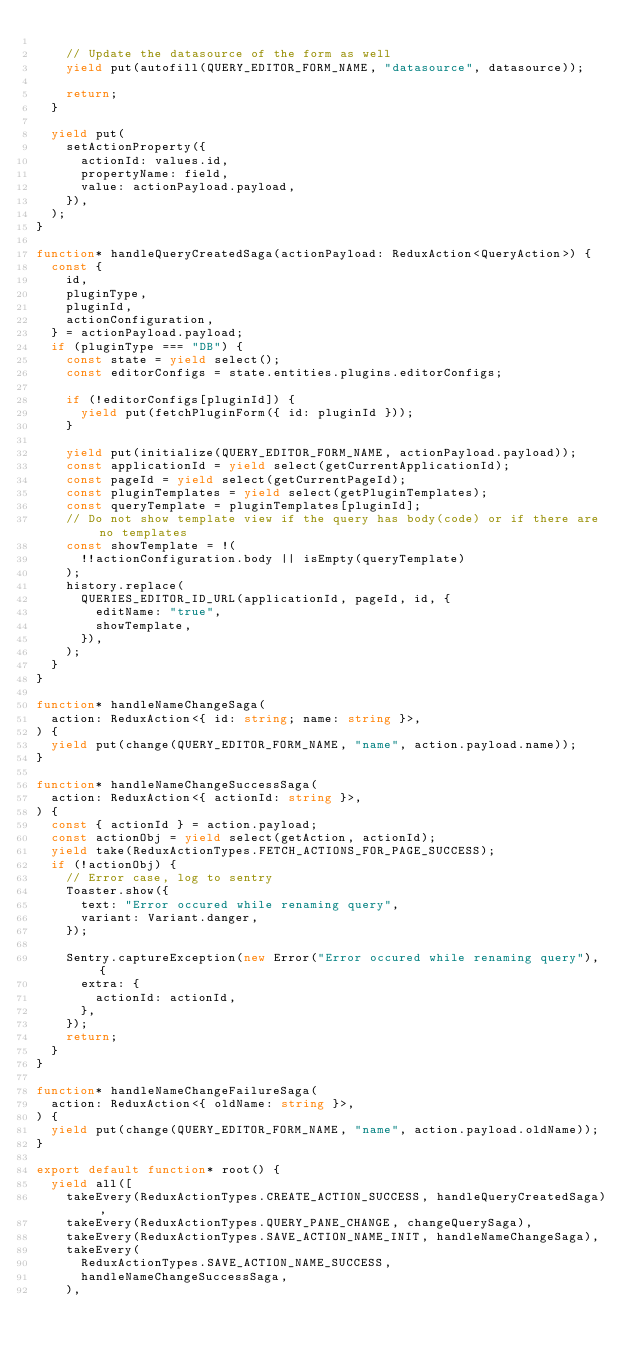<code> <loc_0><loc_0><loc_500><loc_500><_TypeScript_>
    // Update the datasource of the form as well
    yield put(autofill(QUERY_EDITOR_FORM_NAME, "datasource", datasource));

    return;
  }

  yield put(
    setActionProperty({
      actionId: values.id,
      propertyName: field,
      value: actionPayload.payload,
    }),
  );
}

function* handleQueryCreatedSaga(actionPayload: ReduxAction<QueryAction>) {
  const {
    id,
    pluginType,
    pluginId,
    actionConfiguration,
  } = actionPayload.payload;
  if (pluginType === "DB") {
    const state = yield select();
    const editorConfigs = state.entities.plugins.editorConfigs;

    if (!editorConfigs[pluginId]) {
      yield put(fetchPluginForm({ id: pluginId }));
    }

    yield put(initialize(QUERY_EDITOR_FORM_NAME, actionPayload.payload));
    const applicationId = yield select(getCurrentApplicationId);
    const pageId = yield select(getCurrentPageId);
    const pluginTemplates = yield select(getPluginTemplates);
    const queryTemplate = pluginTemplates[pluginId];
    // Do not show template view if the query has body(code) or if there are no templates
    const showTemplate = !(
      !!actionConfiguration.body || isEmpty(queryTemplate)
    );
    history.replace(
      QUERIES_EDITOR_ID_URL(applicationId, pageId, id, {
        editName: "true",
        showTemplate,
      }),
    );
  }
}

function* handleNameChangeSaga(
  action: ReduxAction<{ id: string; name: string }>,
) {
  yield put(change(QUERY_EDITOR_FORM_NAME, "name", action.payload.name));
}

function* handleNameChangeSuccessSaga(
  action: ReduxAction<{ actionId: string }>,
) {
  const { actionId } = action.payload;
  const actionObj = yield select(getAction, actionId);
  yield take(ReduxActionTypes.FETCH_ACTIONS_FOR_PAGE_SUCCESS);
  if (!actionObj) {
    // Error case, log to sentry
    Toaster.show({
      text: "Error occured while renaming query",
      variant: Variant.danger,
    });

    Sentry.captureException(new Error("Error occured while renaming query"), {
      extra: {
        actionId: actionId,
      },
    });
    return;
  }
}

function* handleNameChangeFailureSaga(
  action: ReduxAction<{ oldName: string }>,
) {
  yield put(change(QUERY_EDITOR_FORM_NAME, "name", action.payload.oldName));
}

export default function* root() {
  yield all([
    takeEvery(ReduxActionTypes.CREATE_ACTION_SUCCESS, handleQueryCreatedSaga),
    takeEvery(ReduxActionTypes.QUERY_PANE_CHANGE, changeQuerySaga),
    takeEvery(ReduxActionTypes.SAVE_ACTION_NAME_INIT, handleNameChangeSaga),
    takeEvery(
      ReduxActionTypes.SAVE_ACTION_NAME_SUCCESS,
      handleNameChangeSuccessSaga,
    ),</code> 